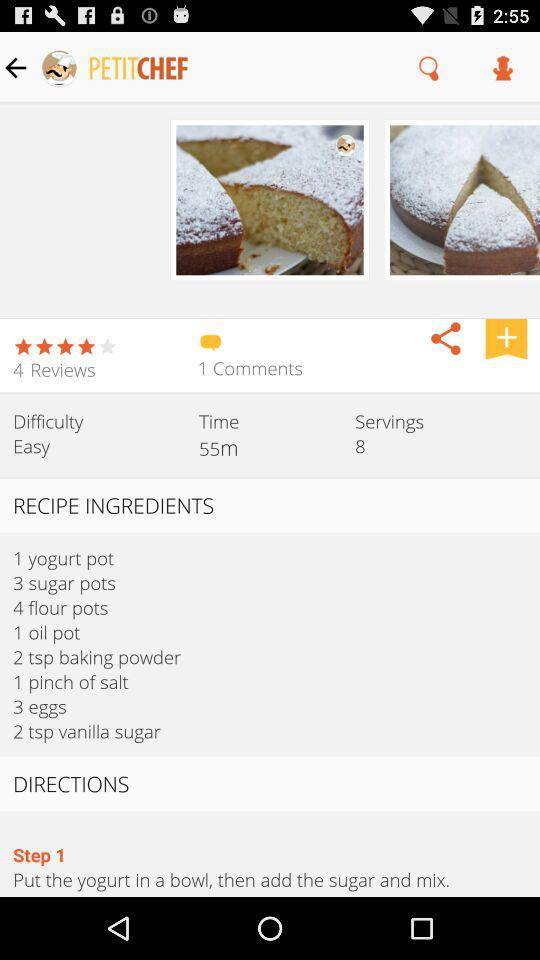How many comments are there? There is 1 comment. 